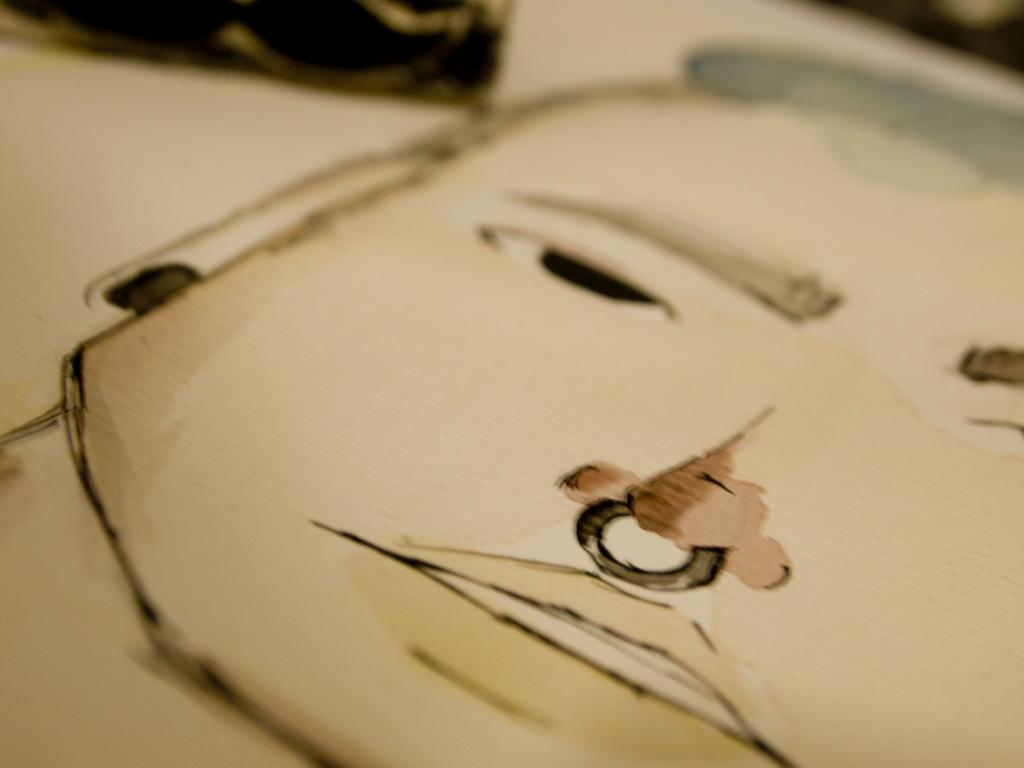What type of image is depicted in the picture? The image appears to be a sketch. Can you hear the person in the sketch crying? There is no person or sound in the sketch, as it is a visual representation and not an audio recording. 